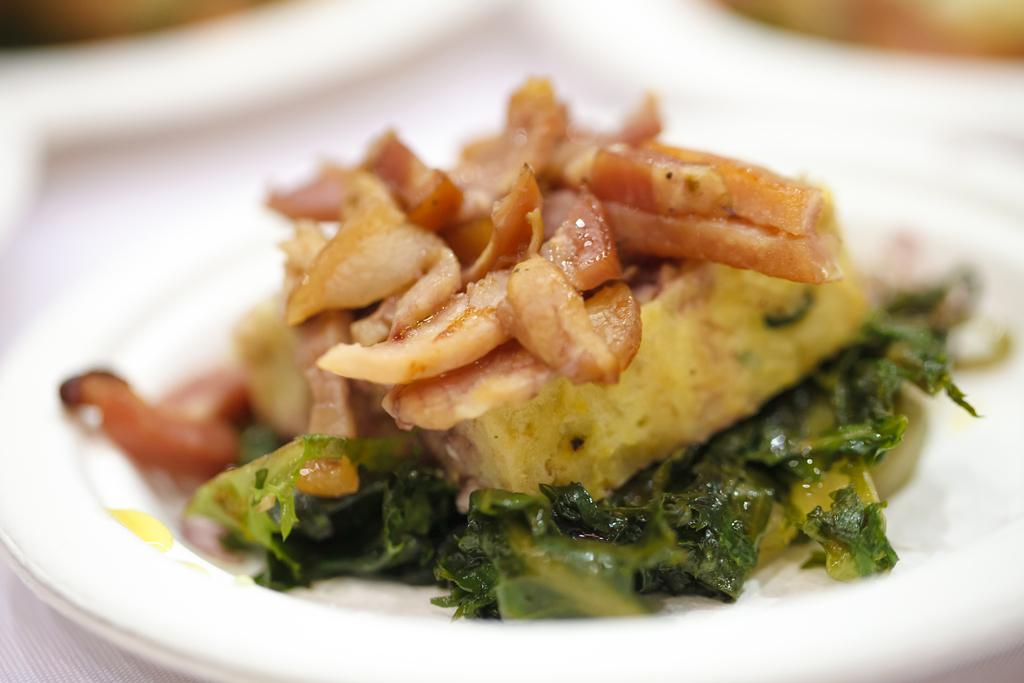What color is the plate in the image? The plate in the image is white colored. What is on the plate? The plate contains a food item. Can you describe the colors of the food item? The food item has green, cream, brown, and yellow colors. How would you describe the background of the image? The background of the image is blurry. What type of apparatus is used to prepare the food item in the image? There is no apparatus visible in the image, and the preparation method of the food item is not mentioned. 